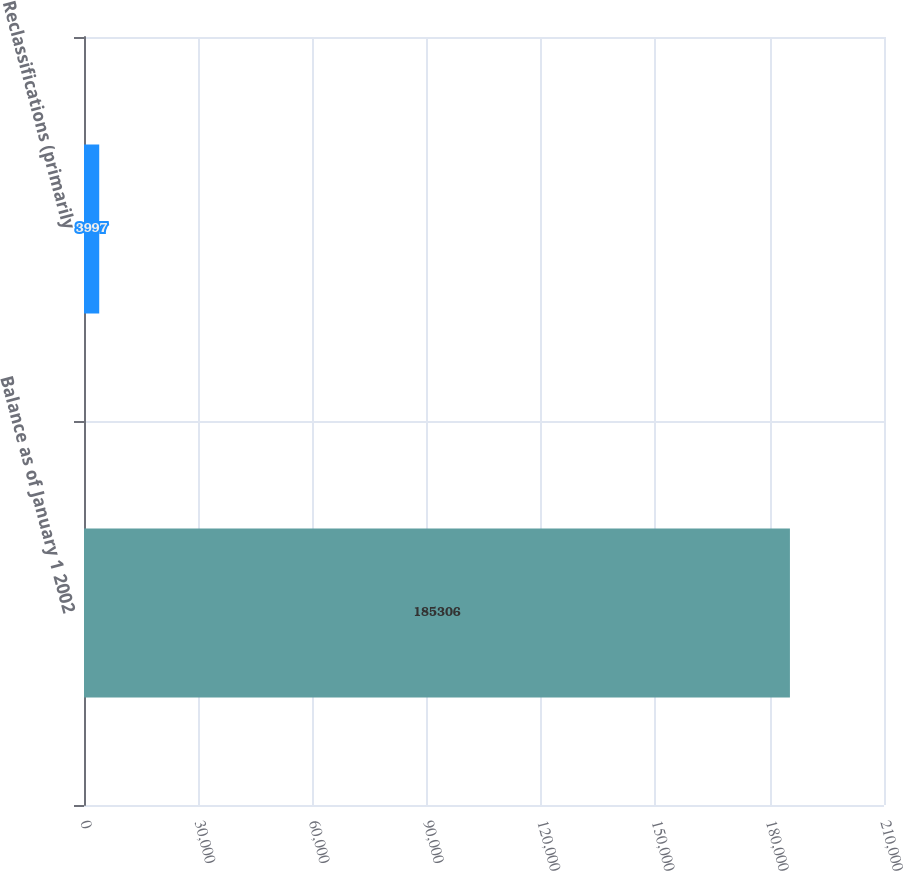<chart> <loc_0><loc_0><loc_500><loc_500><bar_chart><fcel>Balance as of January 1 2002<fcel>Reclassifications (primarily<nl><fcel>185306<fcel>3997<nl></chart> 